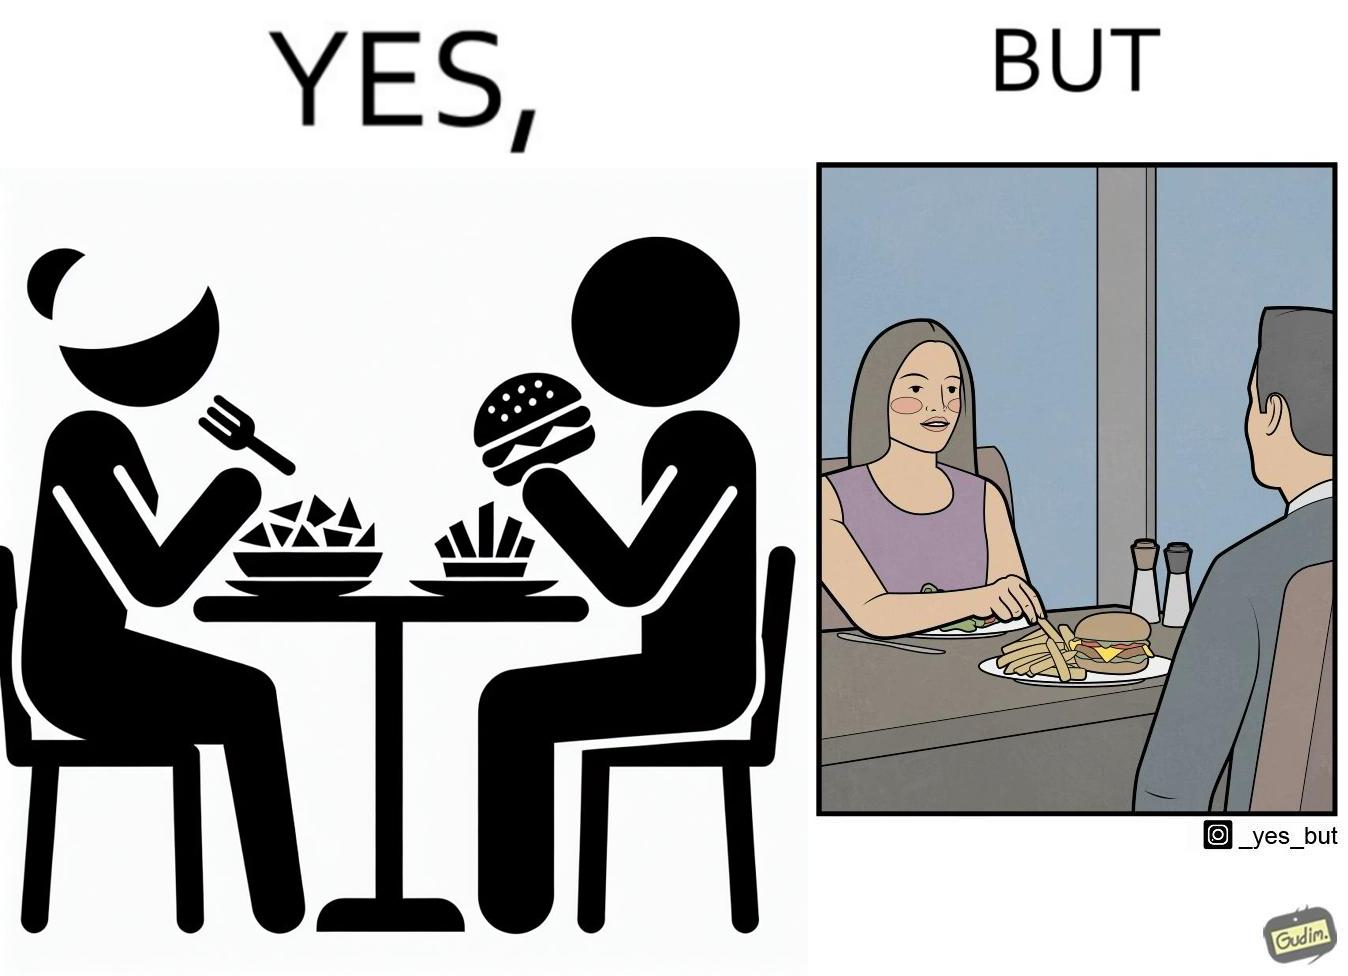What makes this image funny or satirical? The image is ironic because in the first image it is shown that the woman has got salad for her but she is having french fries from the man's plate which displays that the girl is trying to show herself as health conscious by having a plate of salad for her but she wants to have to have fast food but rather than having them for herself she is taking some from other's plate 